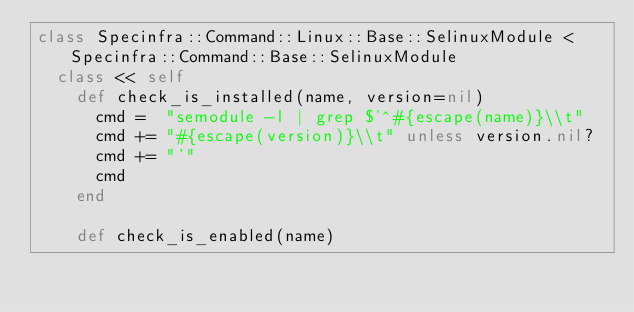Convert code to text. <code><loc_0><loc_0><loc_500><loc_500><_Ruby_>class Specinfra::Command::Linux::Base::SelinuxModule < Specinfra::Command::Base::SelinuxModule
  class << self
    def check_is_installed(name, version=nil)
      cmd =  "semodule -l | grep $'^#{escape(name)}\\t"
      cmd += "#{escape(version)}\\t" unless version.nil?
      cmd += "'"
      cmd
    end

    def check_is_enabled(name)</code> 